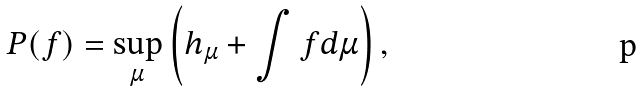<formula> <loc_0><loc_0><loc_500><loc_500>P ( f ) = \sup _ { \mu } \left ( h _ { \mu } + \int f d \mu \right ) ,</formula> 